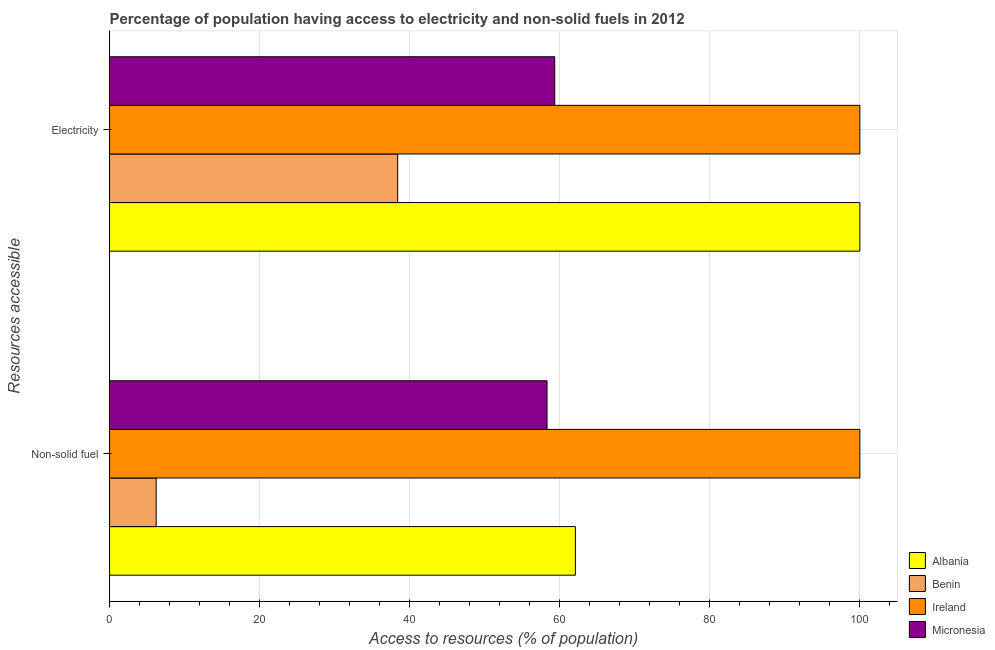Are the number of bars on each tick of the Y-axis equal?
Your answer should be very brief. Yes. How many bars are there on the 1st tick from the bottom?
Your response must be concise. 4. What is the label of the 1st group of bars from the top?
Your response must be concise. Electricity. What is the percentage of population having access to non-solid fuel in Benin?
Give a very brief answer. 6.21. Across all countries, what is the maximum percentage of population having access to non-solid fuel?
Give a very brief answer. 100. Across all countries, what is the minimum percentage of population having access to electricity?
Give a very brief answer. 38.4. In which country was the percentage of population having access to non-solid fuel maximum?
Offer a very short reply. Ireland. In which country was the percentage of population having access to electricity minimum?
Your answer should be compact. Benin. What is the total percentage of population having access to non-solid fuel in the graph?
Offer a very short reply. 226.61. What is the difference between the percentage of population having access to non-solid fuel in Benin and that in Albania?
Give a very brief answer. -55.87. What is the difference between the percentage of population having access to non-solid fuel in Ireland and the percentage of population having access to electricity in Benin?
Provide a short and direct response. 61.6. What is the average percentage of population having access to non-solid fuel per country?
Your response must be concise. 56.65. What is the difference between the percentage of population having access to non-solid fuel and percentage of population having access to electricity in Ireland?
Provide a short and direct response. 0. What is the ratio of the percentage of population having access to non-solid fuel in Ireland to that in Albania?
Offer a very short reply. 1.61. What does the 2nd bar from the top in Electricity represents?
Give a very brief answer. Ireland. What does the 2nd bar from the bottom in Electricity represents?
Provide a succinct answer. Benin. How many bars are there?
Ensure brevity in your answer.  8. Are all the bars in the graph horizontal?
Your response must be concise. Yes. How many countries are there in the graph?
Provide a short and direct response. 4. Does the graph contain any zero values?
Provide a succinct answer. No. Where does the legend appear in the graph?
Provide a short and direct response. Bottom right. How many legend labels are there?
Your response must be concise. 4. What is the title of the graph?
Give a very brief answer. Percentage of population having access to electricity and non-solid fuels in 2012. Does "Switzerland" appear as one of the legend labels in the graph?
Provide a succinct answer. No. What is the label or title of the X-axis?
Make the answer very short. Access to resources (% of population). What is the label or title of the Y-axis?
Your answer should be very brief. Resources accessible. What is the Access to resources (% of population) in Albania in Non-solid fuel?
Provide a succinct answer. 62.09. What is the Access to resources (% of population) in Benin in Non-solid fuel?
Your answer should be very brief. 6.21. What is the Access to resources (% of population) in Ireland in Non-solid fuel?
Offer a terse response. 100. What is the Access to resources (% of population) in Micronesia in Non-solid fuel?
Offer a terse response. 58.31. What is the Access to resources (% of population) in Albania in Electricity?
Ensure brevity in your answer.  100. What is the Access to resources (% of population) in Benin in Electricity?
Make the answer very short. 38.4. What is the Access to resources (% of population) of Ireland in Electricity?
Offer a terse response. 100. What is the Access to resources (% of population) of Micronesia in Electricity?
Offer a terse response. 59.33. Across all Resources accessible, what is the maximum Access to resources (% of population) in Benin?
Your answer should be compact. 38.4. Across all Resources accessible, what is the maximum Access to resources (% of population) of Ireland?
Ensure brevity in your answer.  100. Across all Resources accessible, what is the maximum Access to resources (% of population) of Micronesia?
Your answer should be very brief. 59.33. Across all Resources accessible, what is the minimum Access to resources (% of population) in Albania?
Make the answer very short. 62.09. Across all Resources accessible, what is the minimum Access to resources (% of population) in Benin?
Your answer should be very brief. 6.21. Across all Resources accessible, what is the minimum Access to resources (% of population) of Ireland?
Offer a terse response. 100. Across all Resources accessible, what is the minimum Access to resources (% of population) in Micronesia?
Keep it short and to the point. 58.31. What is the total Access to resources (% of population) in Albania in the graph?
Offer a very short reply. 162.09. What is the total Access to resources (% of population) in Benin in the graph?
Provide a succinct answer. 44.61. What is the total Access to resources (% of population) of Ireland in the graph?
Your answer should be compact. 200. What is the total Access to resources (% of population) of Micronesia in the graph?
Provide a short and direct response. 117.64. What is the difference between the Access to resources (% of population) of Albania in Non-solid fuel and that in Electricity?
Make the answer very short. -37.91. What is the difference between the Access to resources (% of population) in Benin in Non-solid fuel and that in Electricity?
Your response must be concise. -32.19. What is the difference between the Access to resources (% of population) in Micronesia in Non-solid fuel and that in Electricity?
Your answer should be compact. -1.02. What is the difference between the Access to resources (% of population) of Albania in Non-solid fuel and the Access to resources (% of population) of Benin in Electricity?
Your response must be concise. 23.69. What is the difference between the Access to resources (% of population) in Albania in Non-solid fuel and the Access to resources (% of population) in Ireland in Electricity?
Your answer should be compact. -37.91. What is the difference between the Access to resources (% of population) in Albania in Non-solid fuel and the Access to resources (% of population) in Micronesia in Electricity?
Your answer should be very brief. 2.76. What is the difference between the Access to resources (% of population) of Benin in Non-solid fuel and the Access to resources (% of population) of Ireland in Electricity?
Make the answer very short. -93.79. What is the difference between the Access to resources (% of population) of Benin in Non-solid fuel and the Access to resources (% of population) of Micronesia in Electricity?
Offer a terse response. -53.12. What is the difference between the Access to resources (% of population) of Ireland in Non-solid fuel and the Access to resources (% of population) of Micronesia in Electricity?
Your response must be concise. 40.67. What is the average Access to resources (% of population) in Albania per Resources accessible?
Provide a short and direct response. 81.04. What is the average Access to resources (% of population) of Benin per Resources accessible?
Your answer should be very brief. 22.31. What is the average Access to resources (% of population) in Micronesia per Resources accessible?
Ensure brevity in your answer.  58.82. What is the difference between the Access to resources (% of population) of Albania and Access to resources (% of population) of Benin in Non-solid fuel?
Provide a succinct answer. 55.87. What is the difference between the Access to resources (% of population) of Albania and Access to resources (% of population) of Ireland in Non-solid fuel?
Give a very brief answer. -37.91. What is the difference between the Access to resources (% of population) of Albania and Access to resources (% of population) of Micronesia in Non-solid fuel?
Provide a short and direct response. 3.78. What is the difference between the Access to resources (% of population) of Benin and Access to resources (% of population) of Ireland in Non-solid fuel?
Offer a terse response. -93.79. What is the difference between the Access to resources (% of population) in Benin and Access to resources (% of population) in Micronesia in Non-solid fuel?
Offer a very short reply. -52.1. What is the difference between the Access to resources (% of population) of Ireland and Access to resources (% of population) of Micronesia in Non-solid fuel?
Provide a short and direct response. 41.69. What is the difference between the Access to resources (% of population) in Albania and Access to resources (% of population) in Benin in Electricity?
Keep it short and to the point. 61.6. What is the difference between the Access to resources (% of population) in Albania and Access to resources (% of population) in Micronesia in Electricity?
Make the answer very short. 40.67. What is the difference between the Access to resources (% of population) of Benin and Access to resources (% of population) of Ireland in Electricity?
Offer a very short reply. -61.6. What is the difference between the Access to resources (% of population) in Benin and Access to resources (% of population) in Micronesia in Electricity?
Make the answer very short. -20.93. What is the difference between the Access to resources (% of population) in Ireland and Access to resources (% of population) in Micronesia in Electricity?
Make the answer very short. 40.67. What is the ratio of the Access to resources (% of population) of Albania in Non-solid fuel to that in Electricity?
Make the answer very short. 0.62. What is the ratio of the Access to resources (% of population) in Benin in Non-solid fuel to that in Electricity?
Make the answer very short. 0.16. What is the ratio of the Access to resources (% of population) of Ireland in Non-solid fuel to that in Electricity?
Provide a short and direct response. 1. What is the ratio of the Access to resources (% of population) of Micronesia in Non-solid fuel to that in Electricity?
Keep it short and to the point. 0.98. What is the difference between the highest and the second highest Access to resources (% of population) in Albania?
Offer a very short reply. 37.91. What is the difference between the highest and the second highest Access to resources (% of population) in Benin?
Provide a short and direct response. 32.19. What is the difference between the highest and the second highest Access to resources (% of population) in Micronesia?
Give a very brief answer. 1.02. What is the difference between the highest and the lowest Access to resources (% of population) of Albania?
Provide a succinct answer. 37.91. What is the difference between the highest and the lowest Access to resources (% of population) in Benin?
Ensure brevity in your answer.  32.19. What is the difference between the highest and the lowest Access to resources (% of population) in Micronesia?
Offer a very short reply. 1.02. 